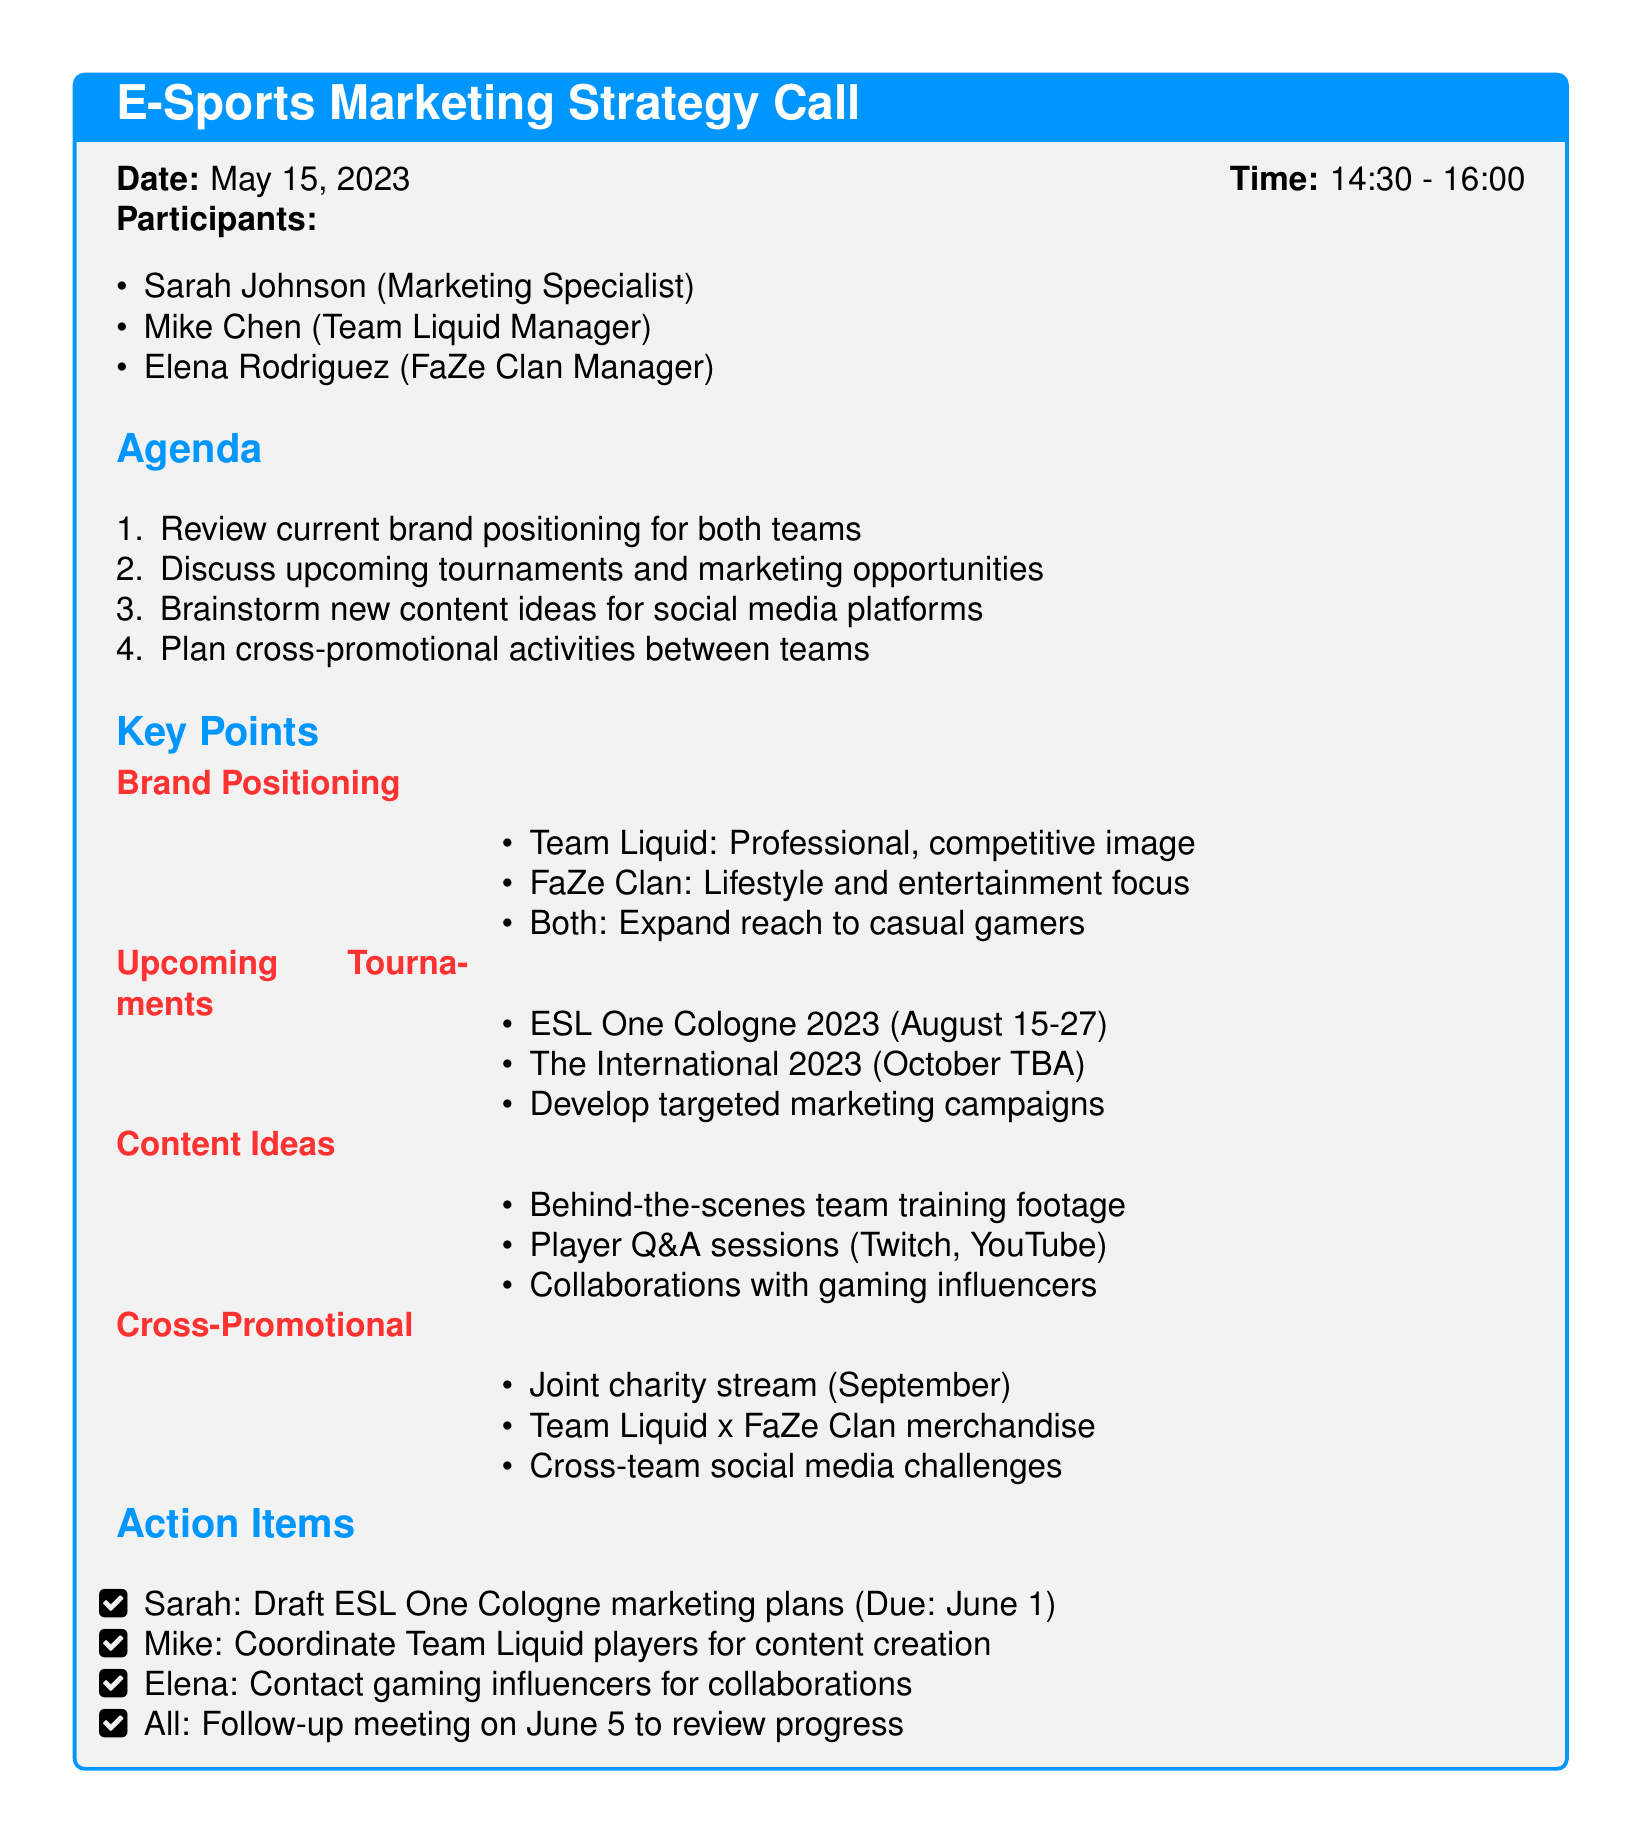What is the date of the call? The date of the call is stated clearly at the top of the document: May 15, 2023.
Answer: May 15, 2023 Who are the participants in the call? The document lists the participants in the section titled "Participants."
Answer: Sarah Johnson, Mike Chen, Elena Rodriguez What is the first agenda item? The first item in the agenda is listed under "Agenda."
Answer: Review current brand positioning for both teams What is the upcoming tournament mentioned in the document? A specific upcoming tournament is provided in the "Upcoming Tournaments" section.
Answer: ESL One Cologne 2023 What marketing campaign is Sarah responsible for? The action item for Sarah includes drafting a specific marketing plan, which is mentioned in the "Action Items" section.
Answer: ESL One Cologne marketing plans What type of content ideas are mentioned for social media? The document lists various content ideas under "Content Ideas," which provide specific examples.
Answer: Behind-the-scenes team training footage How will Team Liquid and FaZe Clan collaborate? The document outlines cross-promotional activities and includes specific plans for collaboration.
Answer: Joint charity stream What is the due date for the marketing plans? The due date for the action item assigned to Sarah is specified in the "Action Items" section.
Answer: June 1 What is the follow-up meeting date? The follow-up meeting date is mentioned in the "Action Items" section, indicating when it is scheduled.
Answer: June 5 